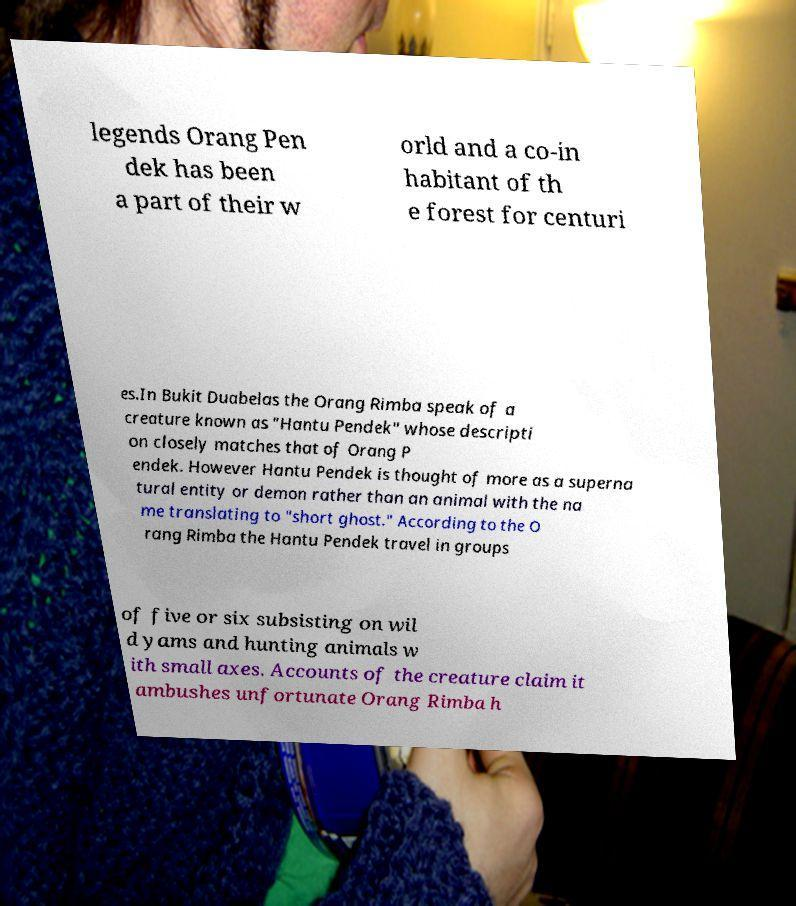There's text embedded in this image that I need extracted. Can you transcribe it verbatim? legends Orang Pen dek has been a part of their w orld and a co-in habitant of th e forest for centuri es.In Bukit Duabelas the Orang Rimba speak of a creature known as "Hantu Pendek" whose descripti on closely matches that of Orang P endek. However Hantu Pendek is thought of more as a superna tural entity or demon rather than an animal with the na me translating to "short ghost." According to the O rang Rimba the Hantu Pendek travel in groups of five or six subsisting on wil d yams and hunting animals w ith small axes. Accounts of the creature claim it ambushes unfortunate Orang Rimba h 